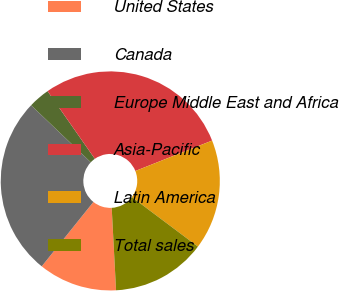<chart> <loc_0><loc_0><loc_500><loc_500><pie_chart><fcel>United States<fcel>Canada<fcel>Europe Middle East and Africa<fcel>Asia-Pacific<fcel>Latin America<fcel>Total sales<nl><fcel>11.6%<fcel>26.37%<fcel>3.16%<fcel>28.69%<fcel>16.24%<fcel>13.92%<nl></chart> 